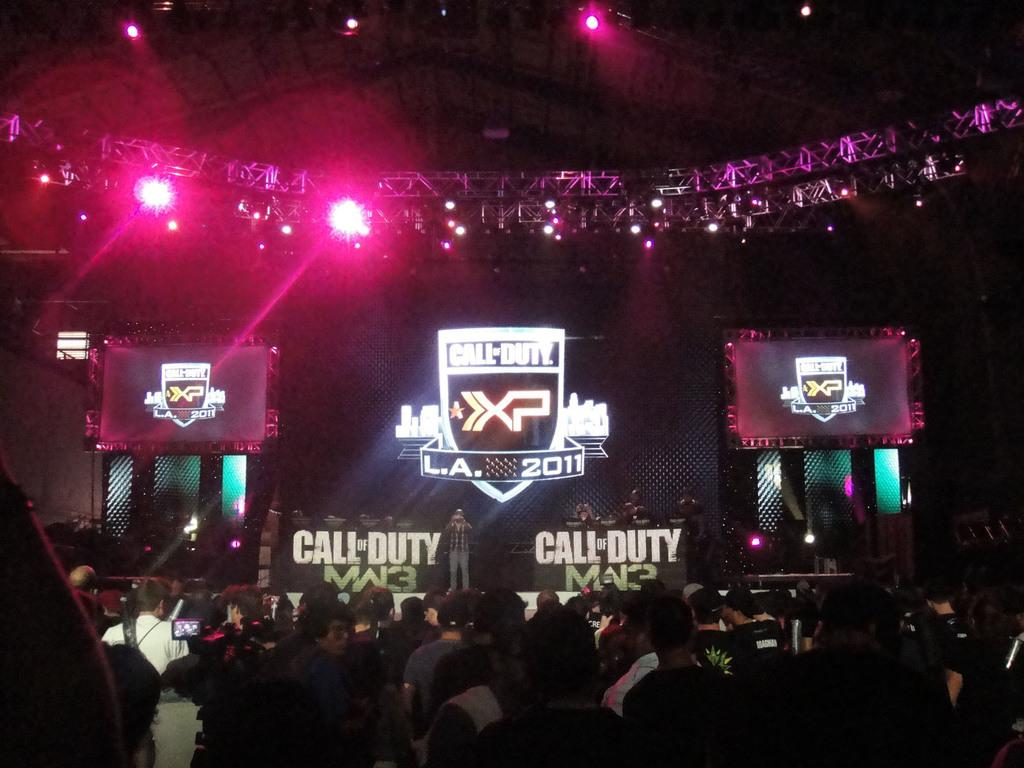What is the person in the image doing? There is a person standing on the stage in the image. What can be seen in the background of the image? There are boards visible in the image. What is providing illumination in the image? There is lighting in the image. What is covering the area above the stage? There is a roof in the image. Who else is present in the image besides the person on the stage? There is a group of people standing beside the stage. What type of honey is being taught by the person on the stage? There is no honey or teaching present in the image; it only shows a person standing on the stage and a group of people beside it. 